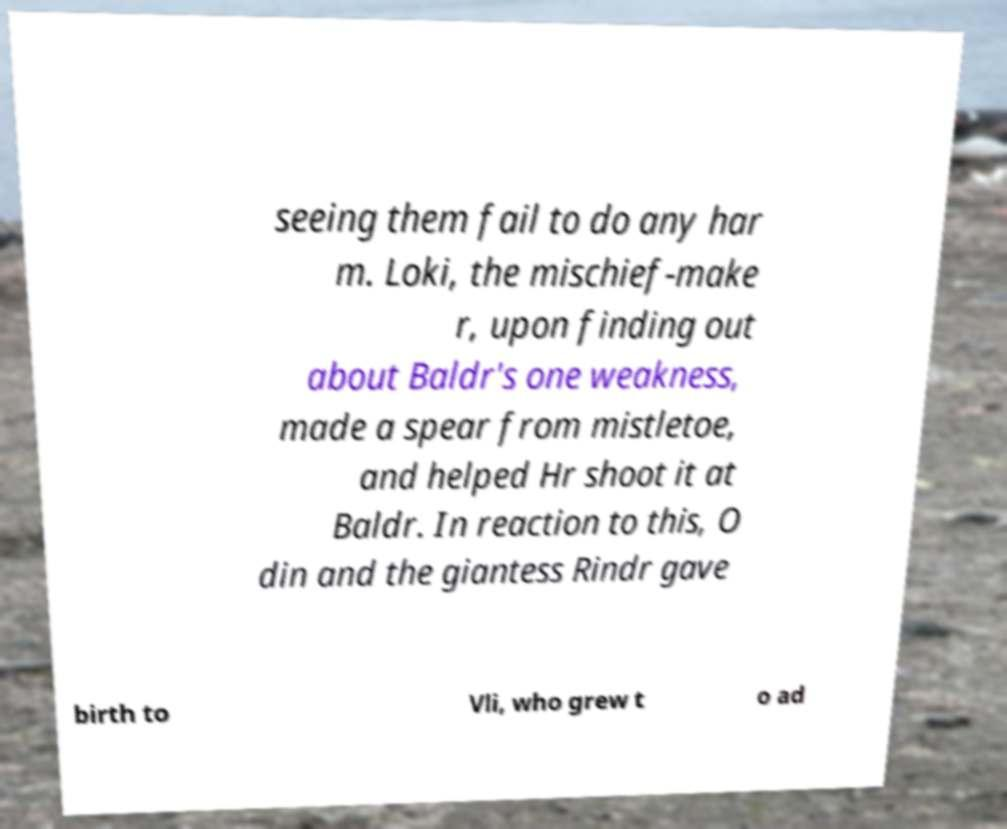What messages or text are displayed in this image? I need them in a readable, typed format. seeing them fail to do any har m. Loki, the mischief-make r, upon finding out about Baldr's one weakness, made a spear from mistletoe, and helped Hr shoot it at Baldr. In reaction to this, O din and the giantess Rindr gave birth to Vli, who grew t o ad 